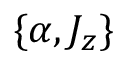Convert formula to latex. <formula><loc_0><loc_0><loc_500><loc_500>\{ \alpha , J _ { z } \}</formula> 